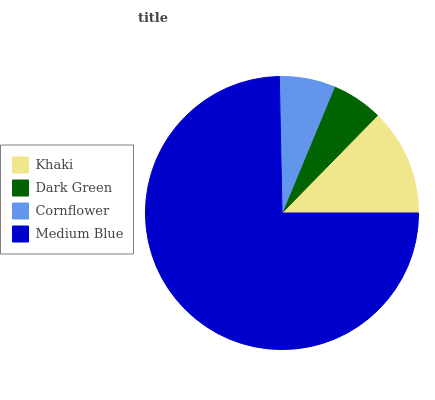Is Dark Green the minimum?
Answer yes or no. Yes. Is Medium Blue the maximum?
Answer yes or no. Yes. Is Cornflower the minimum?
Answer yes or no. No. Is Cornflower the maximum?
Answer yes or no. No. Is Cornflower greater than Dark Green?
Answer yes or no. Yes. Is Dark Green less than Cornflower?
Answer yes or no. Yes. Is Dark Green greater than Cornflower?
Answer yes or no. No. Is Cornflower less than Dark Green?
Answer yes or no. No. Is Khaki the high median?
Answer yes or no. Yes. Is Cornflower the low median?
Answer yes or no. Yes. Is Cornflower the high median?
Answer yes or no. No. Is Khaki the low median?
Answer yes or no. No. 